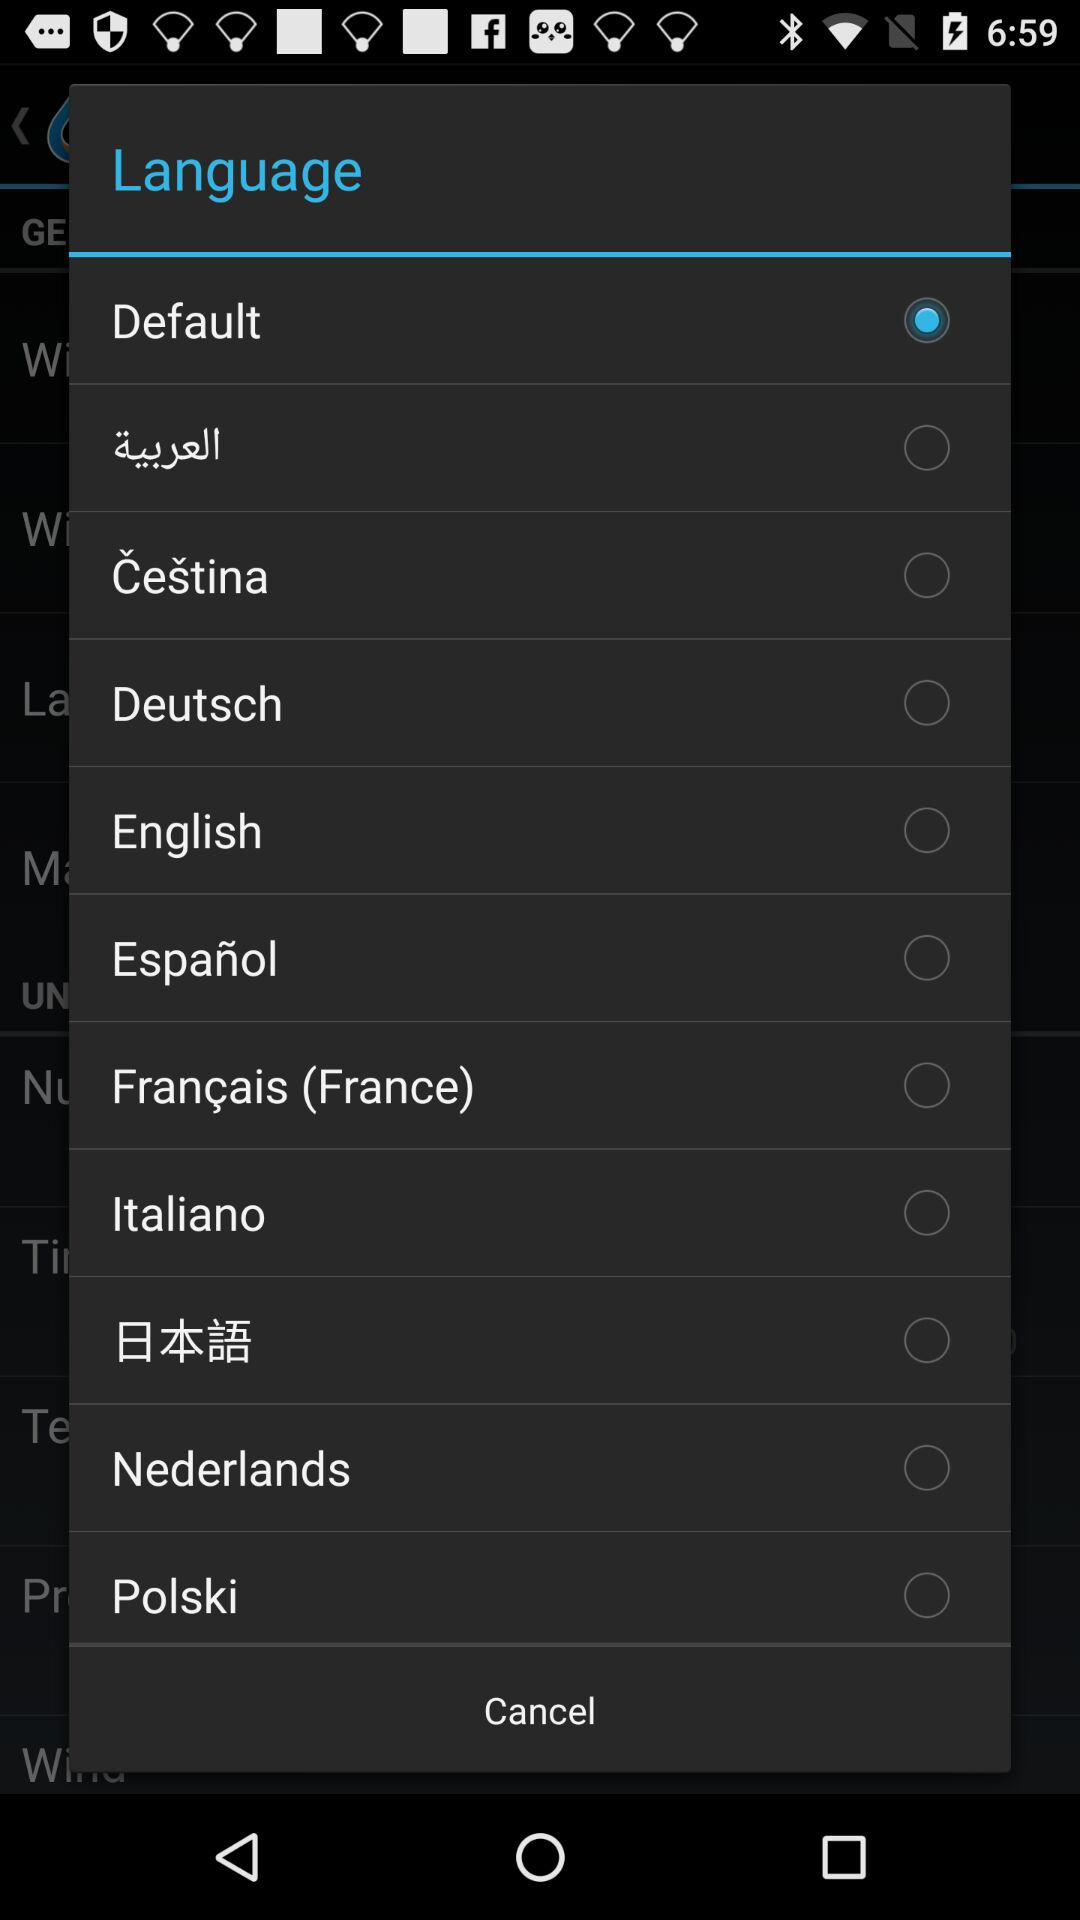Which language is selected? The selected language is "Default". 